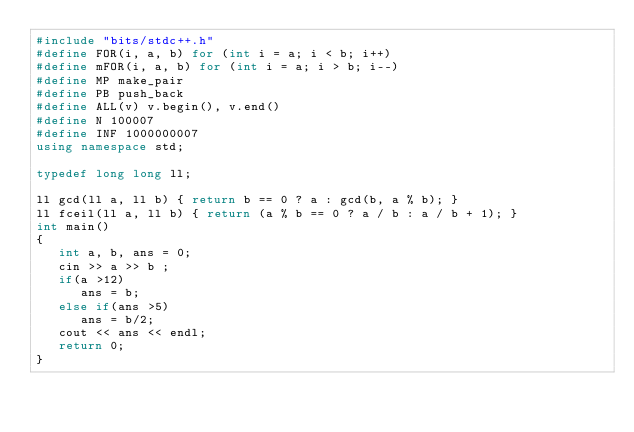<code> <loc_0><loc_0><loc_500><loc_500><_C++_>#include "bits/stdc++.h"
#define FOR(i, a, b) for (int i = a; i < b; i++)
#define mFOR(i, a, b) for (int i = a; i > b; i--)
#define MP make_pair
#define PB push_back
#define ALL(v) v.begin(), v.end()
#define N 100007
#define INF 1000000007
using namespace std;

typedef long long ll;

ll gcd(ll a, ll b) { return b == 0 ? a : gcd(b, a % b); }
ll fceil(ll a, ll b) { return (a % b == 0 ? a / b : a / b + 1); }
int main()
{ 
   int a, b, ans = 0;
   cin >> a >> b ;
   if(a >12)
      ans = b;
   else if(ans >5)
      ans = b/2;
   cout << ans << endl;
   return 0;
}
</code> 